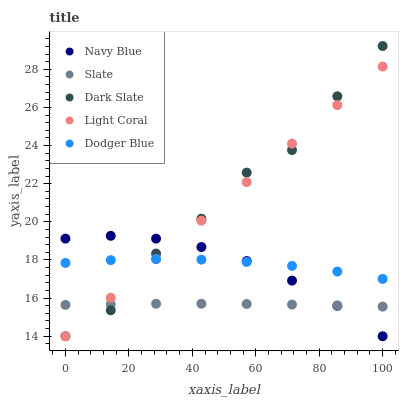Does Slate have the minimum area under the curve?
Answer yes or no. Yes. Does Dark Slate have the maximum area under the curve?
Answer yes or no. Yes. Does Navy Blue have the minimum area under the curve?
Answer yes or no. No. Does Navy Blue have the maximum area under the curve?
Answer yes or no. No. Is Light Coral the smoothest?
Answer yes or no. Yes. Is Dark Slate the roughest?
Answer yes or no. Yes. Is Navy Blue the smoothest?
Answer yes or no. No. Is Navy Blue the roughest?
Answer yes or no. No. Does Light Coral have the lowest value?
Answer yes or no. Yes. Does Slate have the lowest value?
Answer yes or no. No. Does Dark Slate have the highest value?
Answer yes or no. Yes. Does Navy Blue have the highest value?
Answer yes or no. No. Is Slate less than Dodger Blue?
Answer yes or no. Yes. Is Dodger Blue greater than Slate?
Answer yes or no. Yes. Does Slate intersect Light Coral?
Answer yes or no. Yes. Is Slate less than Light Coral?
Answer yes or no. No. Is Slate greater than Light Coral?
Answer yes or no. No. Does Slate intersect Dodger Blue?
Answer yes or no. No. 